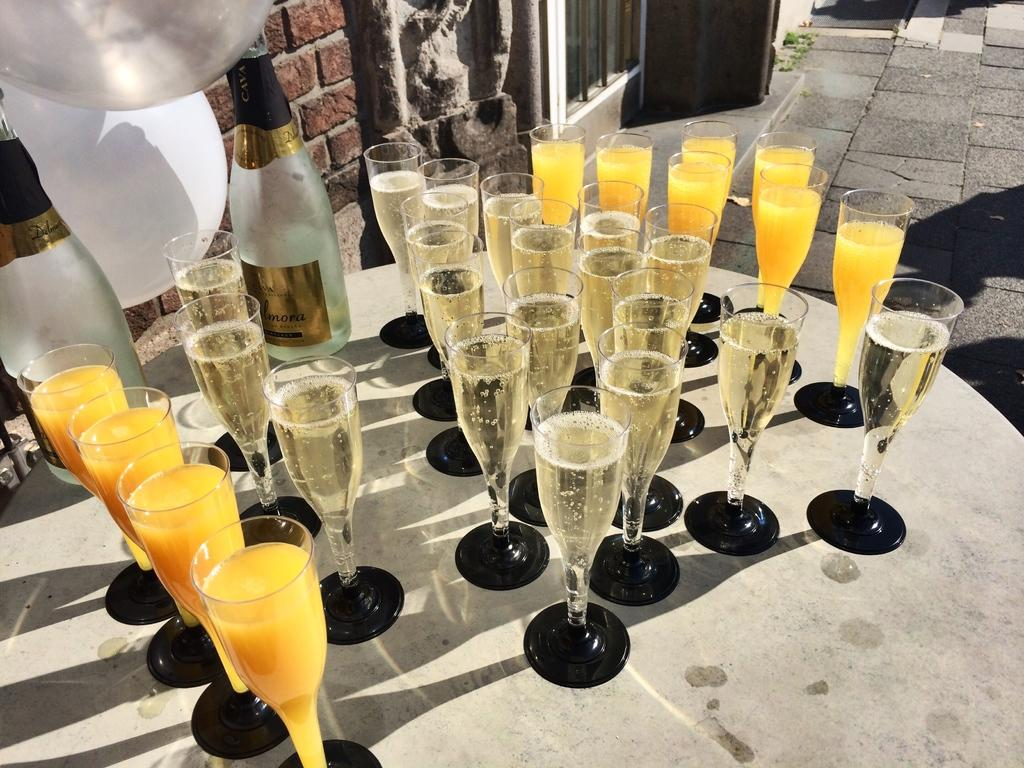What is located in the center of the image? There is a table in the center of the image. What type of glasses can be seen on the table? Juice glasses and wine glasses are present on the table. What other items related to wine can be seen on the table? Wine bottles are present on the table. What can be seen in the background of the image? There is a brick wall, a balloon, grass, and a door in the background of the image. Where is the crate of apples located in the image? There is no crate of apples present in the image. What type of ticket is visible in the image? There is no ticket visible in the image. 